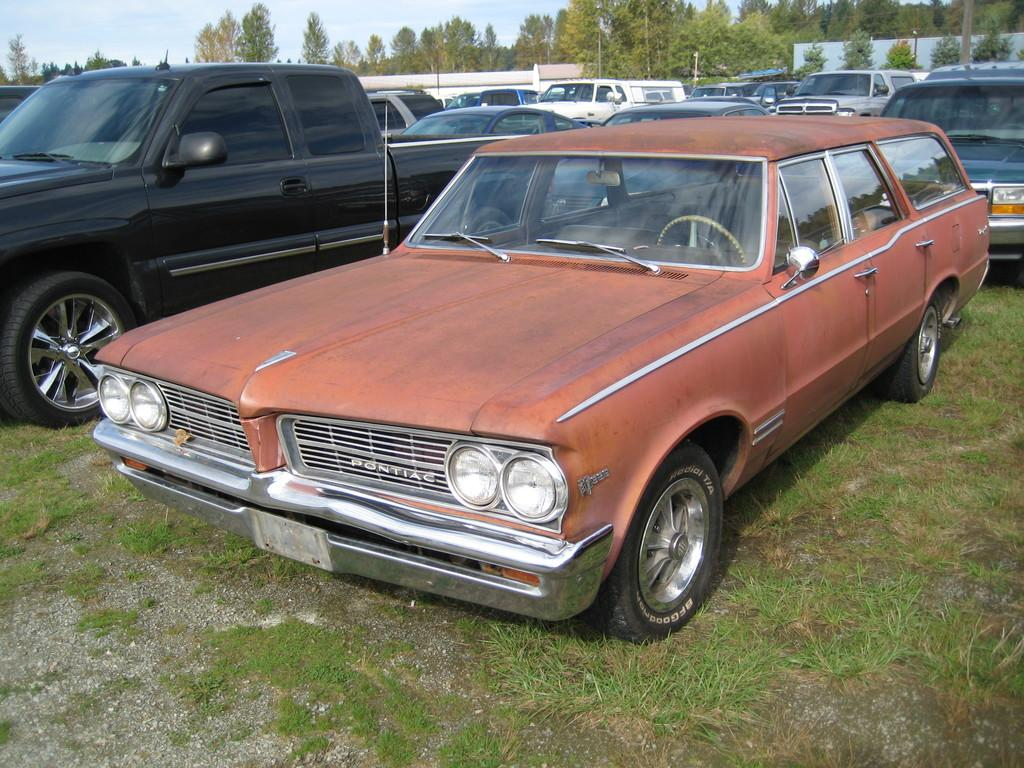What type of vehicles are present in the image? There are fleets of cars in the image. Where are the cars located? The cars are on grass in the image. What other natural elements can be seen in the image? There are trees in the image. What is the boundary in the image? There is a fence in the image. What is visible in the background of the image? The sky is visible in the image. What might be the location of the image based on the surroundings? The image may have been taken in a park, given the presence of grass, trees, and a fence. What is the chance of finding a drain in the image? There is no mention of a drain in the image, so it cannot be determined if there is a chance of finding one. 